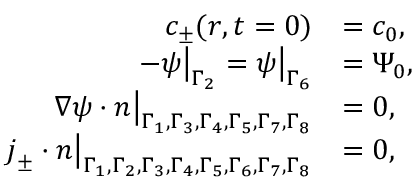Convert formula to latex. <formula><loc_0><loc_0><loc_500><loc_500>\begin{array} { r l } { c _ { \pm } ( r , t = 0 ) } & { = c _ { 0 } , } \\ { - \psi \left | _ { \Gamma _ { 2 } } = \psi \right | _ { \Gamma _ { 6 } } } & { = \Psi _ { 0 } , } \\ { \nabla \psi \cdot n \left | _ { \Gamma _ { 1 } , \Gamma _ { 3 } , \Gamma _ { 4 } , \Gamma _ { 5 } , \Gamma _ { 7 } , \Gamma _ { 8 } } } & { = 0 , } \\ { j _ { \pm } \cdot n \right | _ { \Gamma _ { 1 } , \Gamma _ { 2 } , \Gamma _ { 3 } , \Gamma _ { 4 } , \Gamma _ { 5 } , \Gamma _ { 6 } , \Gamma _ { 7 } , \Gamma _ { 8 } } } & { = 0 , } \end{array}</formula> 